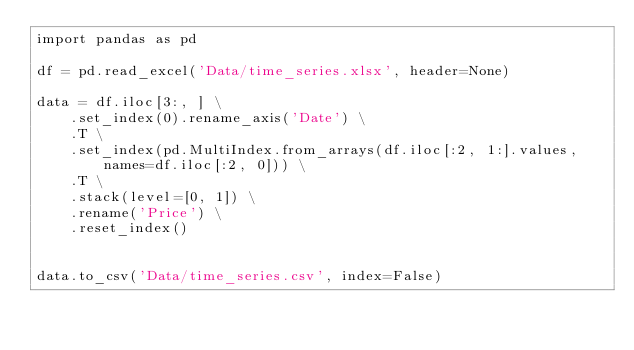Convert code to text. <code><loc_0><loc_0><loc_500><loc_500><_Python_>import pandas as pd

df = pd.read_excel('Data/time_series.xlsx', header=None)

data = df.iloc[3:, ] \
    .set_index(0).rename_axis('Date') \
    .T \
    .set_index(pd.MultiIndex.from_arrays(df.iloc[:2, 1:].values, names=df.iloc[:2, 0])) \
    .T \
    .stack(level=[0, 1]) \
    .rename('Price') \
    .reset_index()


data.to_csv('Data/time_series.csv', index=False)
</code> 